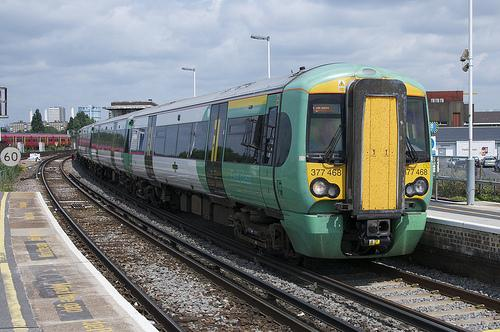What color is the line painted on the sidewalk near the tracks? The painted line on the sidewalk near the tracks is yellow. List the colors and objects associated with another train that appears in the background of the image. A long red train can be seen at a distance in the background of the image. How many sets of tracks can be seen in the image and what is the color of the gravel between them? There are two sets of tracks, and the gravel between them is gray. In the image, what is the weather like, and what is the condition of the sky? The weather appears to be cloudy and overcast with white clouds filling the sky. What kind of structure is adjacent to the train tracks and parking lot in the image? A building can be seen next to the train tracks and parking lot. What number can be seen on a sign and on the main train in the image? The number 60 can be seen on a sign and on the main train. Discuss the state of the headlights on the main train in the image. The headlights of the main train are off but they are white in color. Mention the colors and type of the main train in the image. The main train is green, yellow and white on the exterior, and is a passenger train. Identify some items and their respective colors that can be found between or beneath the train tracks in the image. Grey gravel, brown railroad ties, and black rails can be found between or beneath the train tracks. Please describe the appearance and color of the door in the front of the main train. The door in the front of the main train is yellow, and it seems to be a standard train door. 